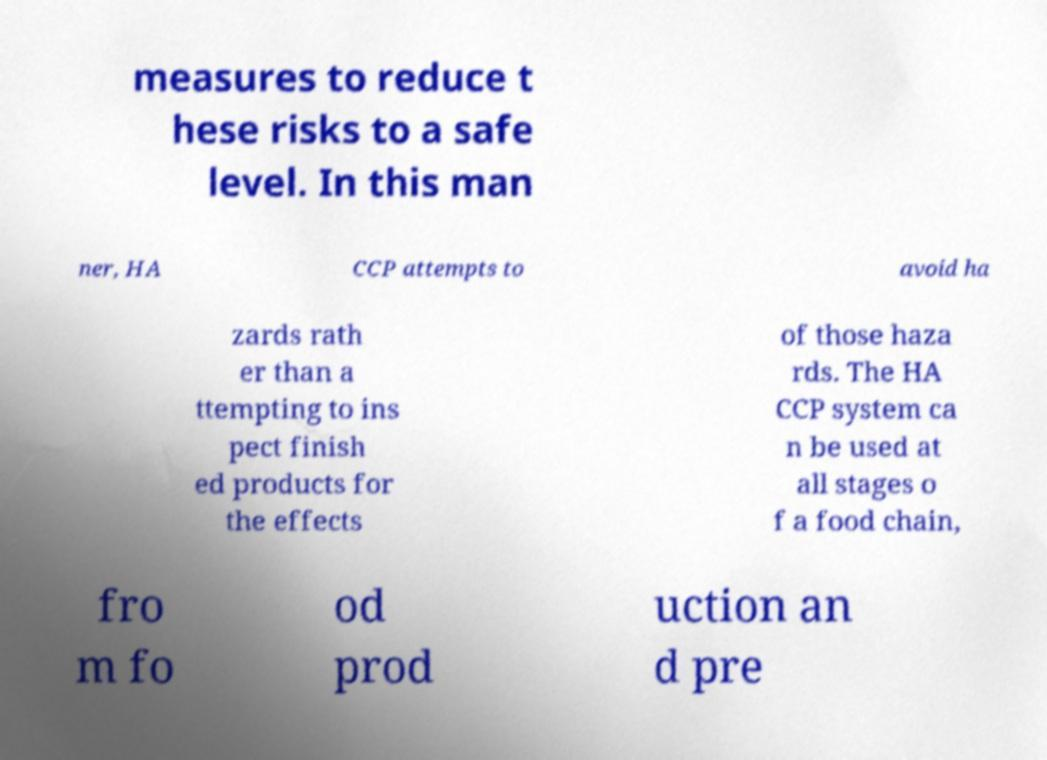Could you extract and type out the text from this image? measures to reduce t hese risks to a safe level. In this man ner, HA CCP attempts to avoid ha zards rath er than a ttempting to ins pect finish ed products for the effects of those haza rds. The HA CCP system ca n be used at all stages o f a food chain, fro m fo od prod uction an d pre 